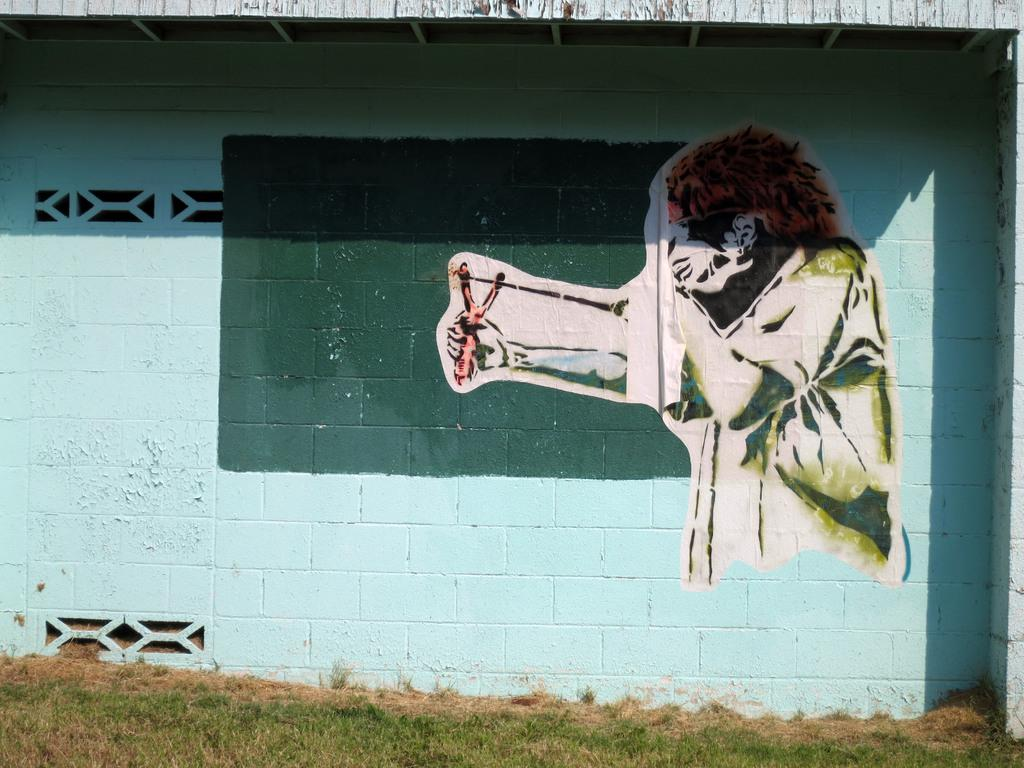What is depicted in the painting that is visible in the image? There is a painting of a person in the image. Where is the painting located? The painting is on a wall. What type of natural environment can be seen at the bottom of the image? There is grass visible at the bottom of the image. How many accounts are mentioned in the painting? There are no accounts mentioned in the painting, as it is a visual representation of a person and not a written or numerical document. 